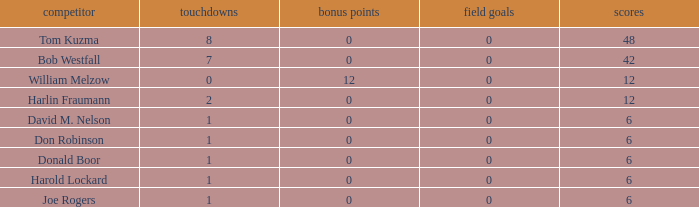Name the least touchdowns for joe rogers 1.0. 